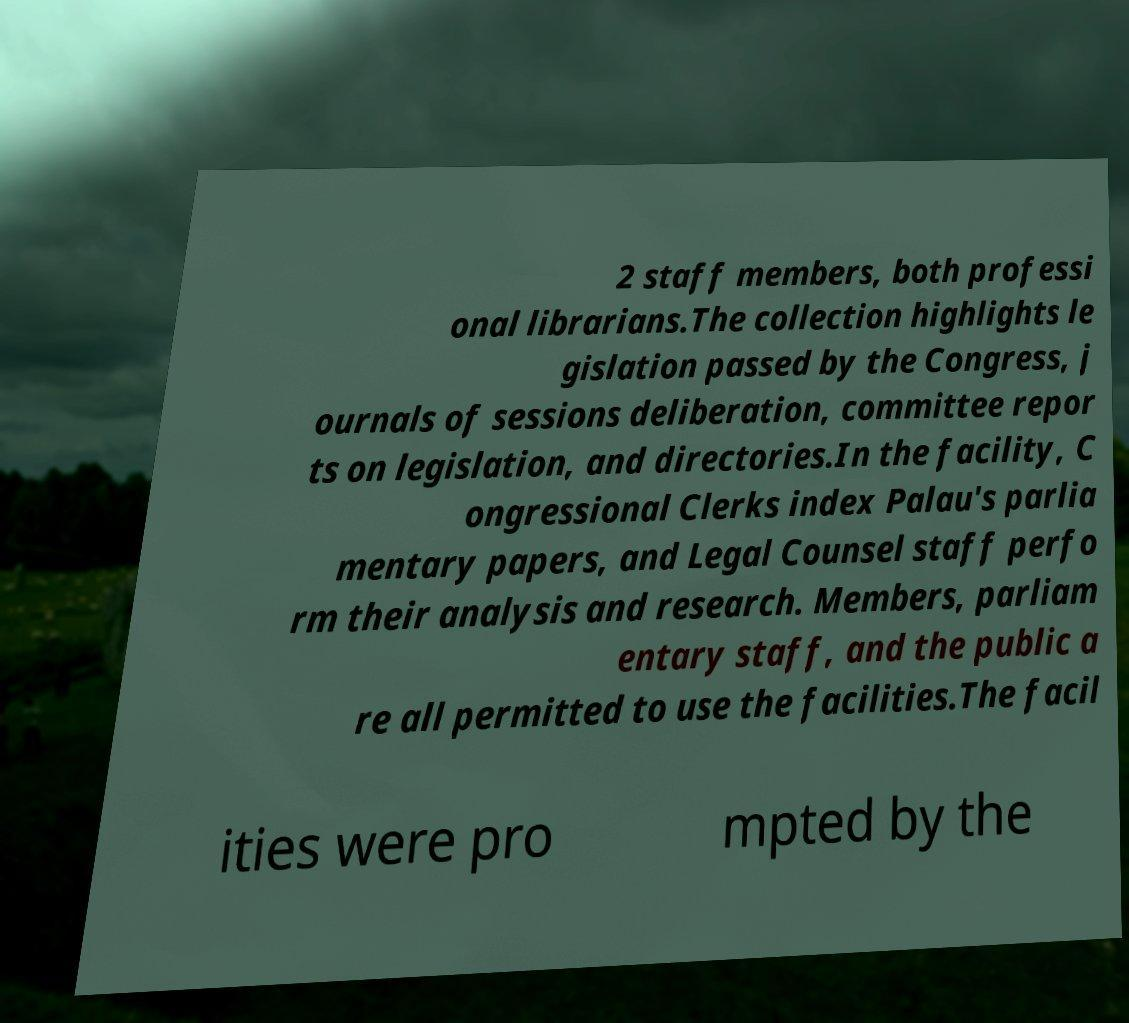Can you accurately transcribe the text from the provided image for me? 2 staff members, both professi onal librarians.The collection highlights le gislation passed by the Congress, j ournals of sessions deliberation, committee repor ts on legislation, and directories.In the facility, C ongressional Clerks index Palau's parlia mentary papers, and Legal Counsel staff perfo rm their analysis and research. Members, parliam entary staff, and the public a re all permitted to use the facilities.The facil ities were pro mpted by the 